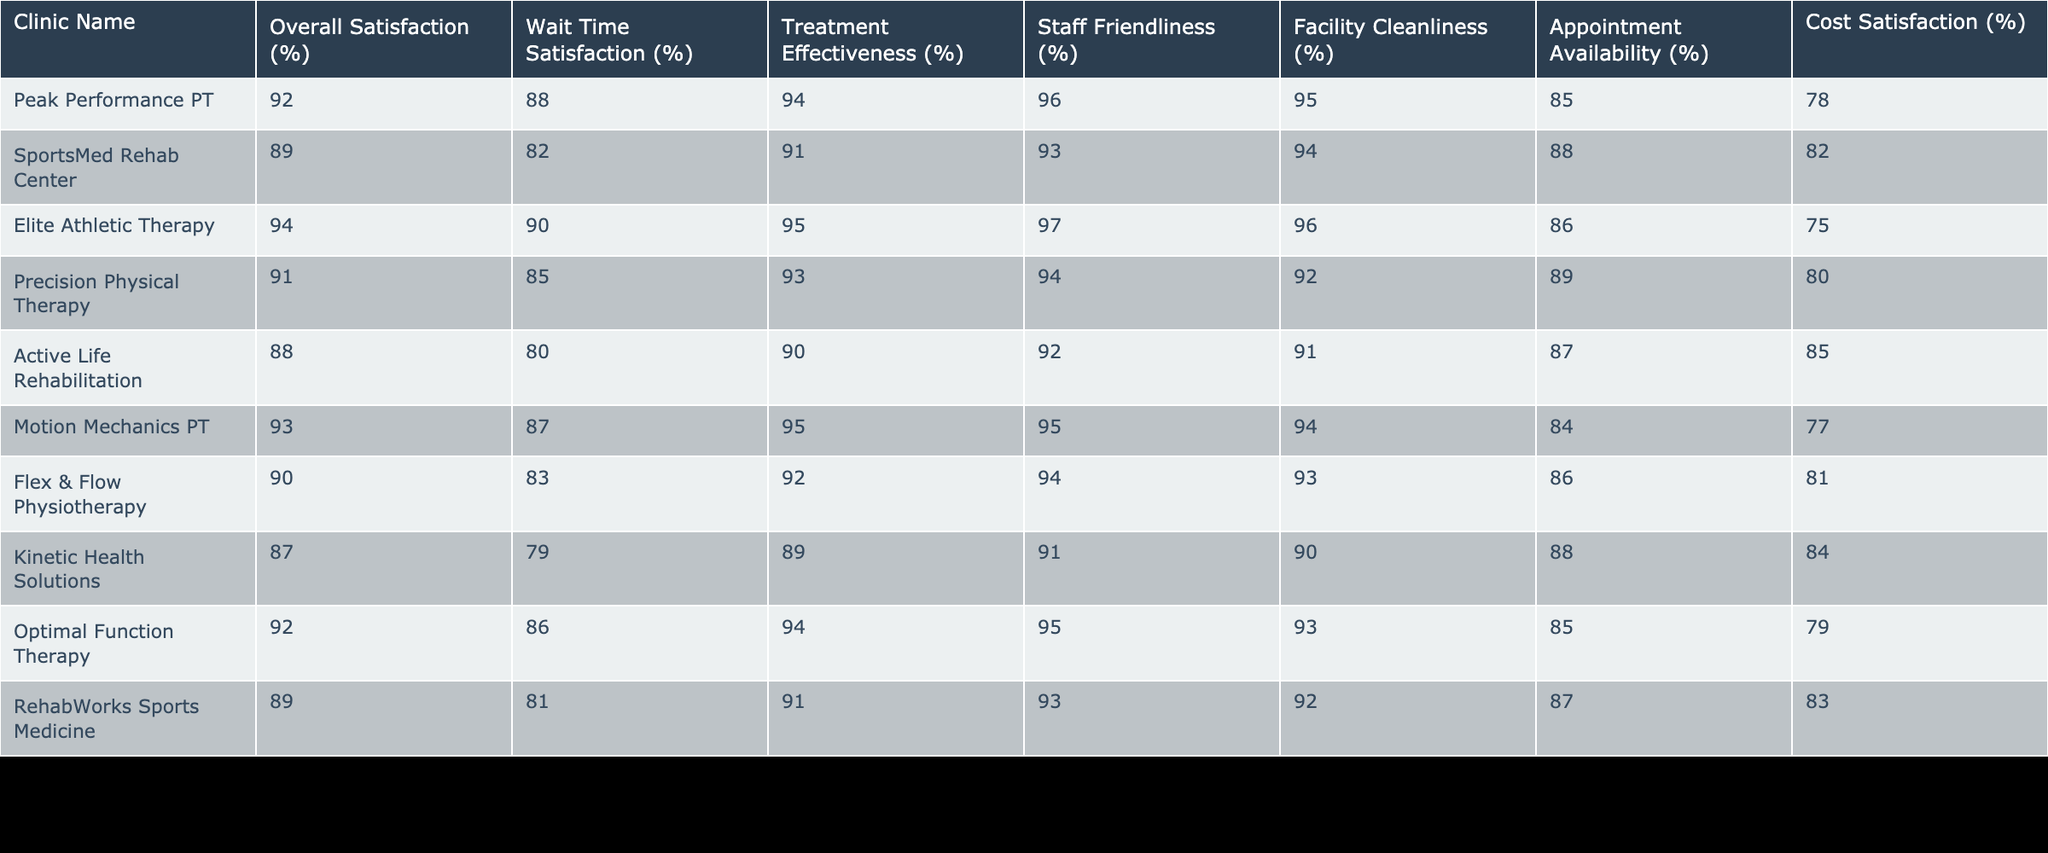What is the overall satisfaction percentage for Elite Athletic Therapy? The table shows that the overall satisfaction percentage for Elite Athletic Therapy is 94%.
Answer: 94% Which clinic has the highest treatment effectiveness score? According to the table, Elite Athletic Therapy has the highest treatment effectiveness score at 95%.
Answer: Elite Athletic Therapy What percentage of patients at SportsMed Rehab Center are satisfied with their wait time? The table indicates that SportsMed Rehab Center has a wait time satisfaction percentage of 82%.
Answer: 82% Is the facility cleanliness percentage for Motion Mechanics PT greater than that of Active Life Rehabilitation? The table shows that Motion Mechanics PT has a facility cleanliness percentage of 94%, while Active Life Rehabilitation has a cleanliness percentage of 91%. Since 94 is greater than 91, the statement is true.
Answer: Yes What is the average appointment availability score for the clinics listed in the table? To calculate the average appointment availability score, we add the scores: 85 + 88 + 86 + 89 + 87 + 84 + 88 + 85 + 87 + 86 = 867. There are 10 clinics, so the average appointment availability score is 867 divided by 10, which equals 86.7.
Answer: 86.7 How does the overall satisfaction of Optimal Function Therapy compare with that of Kinetic Health Solutions? The overall satisfaction rate for Optimal Function Therapy is 92%, which is higher than Kinetic Health Solutions' rate of 87%. Therefore, Optimal Function Therapy has a better overall satisfaction percentage compared to Kinetic Health Solutions.
Answer: Higher What is the difference between the treatment effectiveness scores of Elite Athletic Therapy and Precision Physical Therapy? Elite Athletic Therapy has a treatment effectiveness score of 95%, while Precision Physical Therapy's score is 93%. The difference is 95 - 93 = 2.
Answer: 2 Which clinic has both the highest staff friendliness percentage and the highest facility cleanliness percentage? According to the table, Elite Athletic Therapy has both the highest staff friendliness percentage (97%) and the highest facility cleanliness percentage (96%), making it the clinic with these highest ratings.
Answer: Elite Athletic Therapy Do patients at Flex & Flow Physiotherapy report higher satisfaction with cost compared to the patients at Optimal Function Therapy? Flex & Flow Physiotherapy has a cost satisfaction percentage of 81%, while Optimal Function Therapy has a cost satisfaction percentage of 79%. Since 81 is greater than 79, the answer is yes.
Answer: Yes 